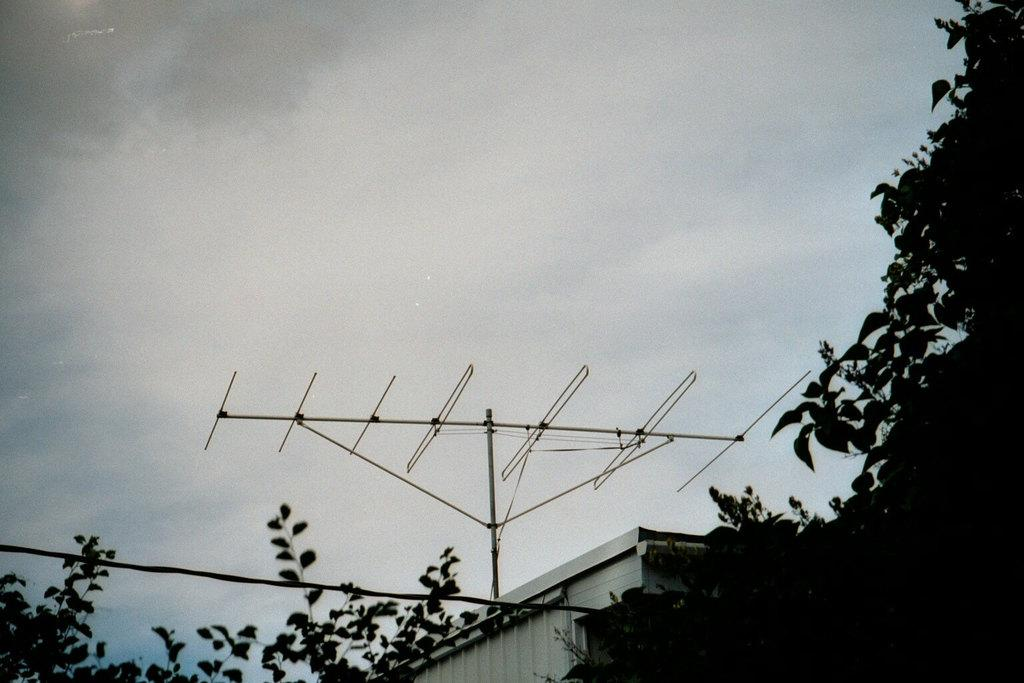What is located on the top of the building in the image? There is an antenna on the top of the building in the image. What can be seen in the background of the image? The background of the image is the sky. What type of toothbrush is hanging from the antenna in the image? There is no toothbrush present in the image, as it only features an antenna on a building with a sky background. 